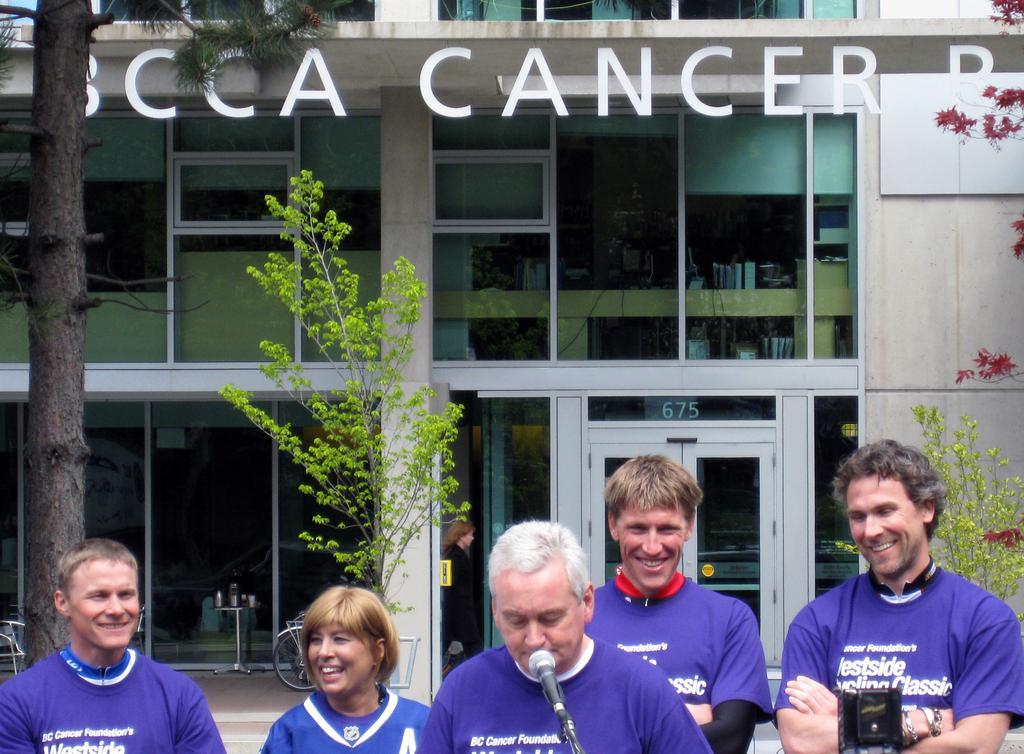Describe this image in one or two sentences. At the bottom of the image, we can see people, microphone and black object. Few people are smiling. In the background, we can see building, wall, plants, person, walkway, tables, glass objects, door, vehicle and few things. 